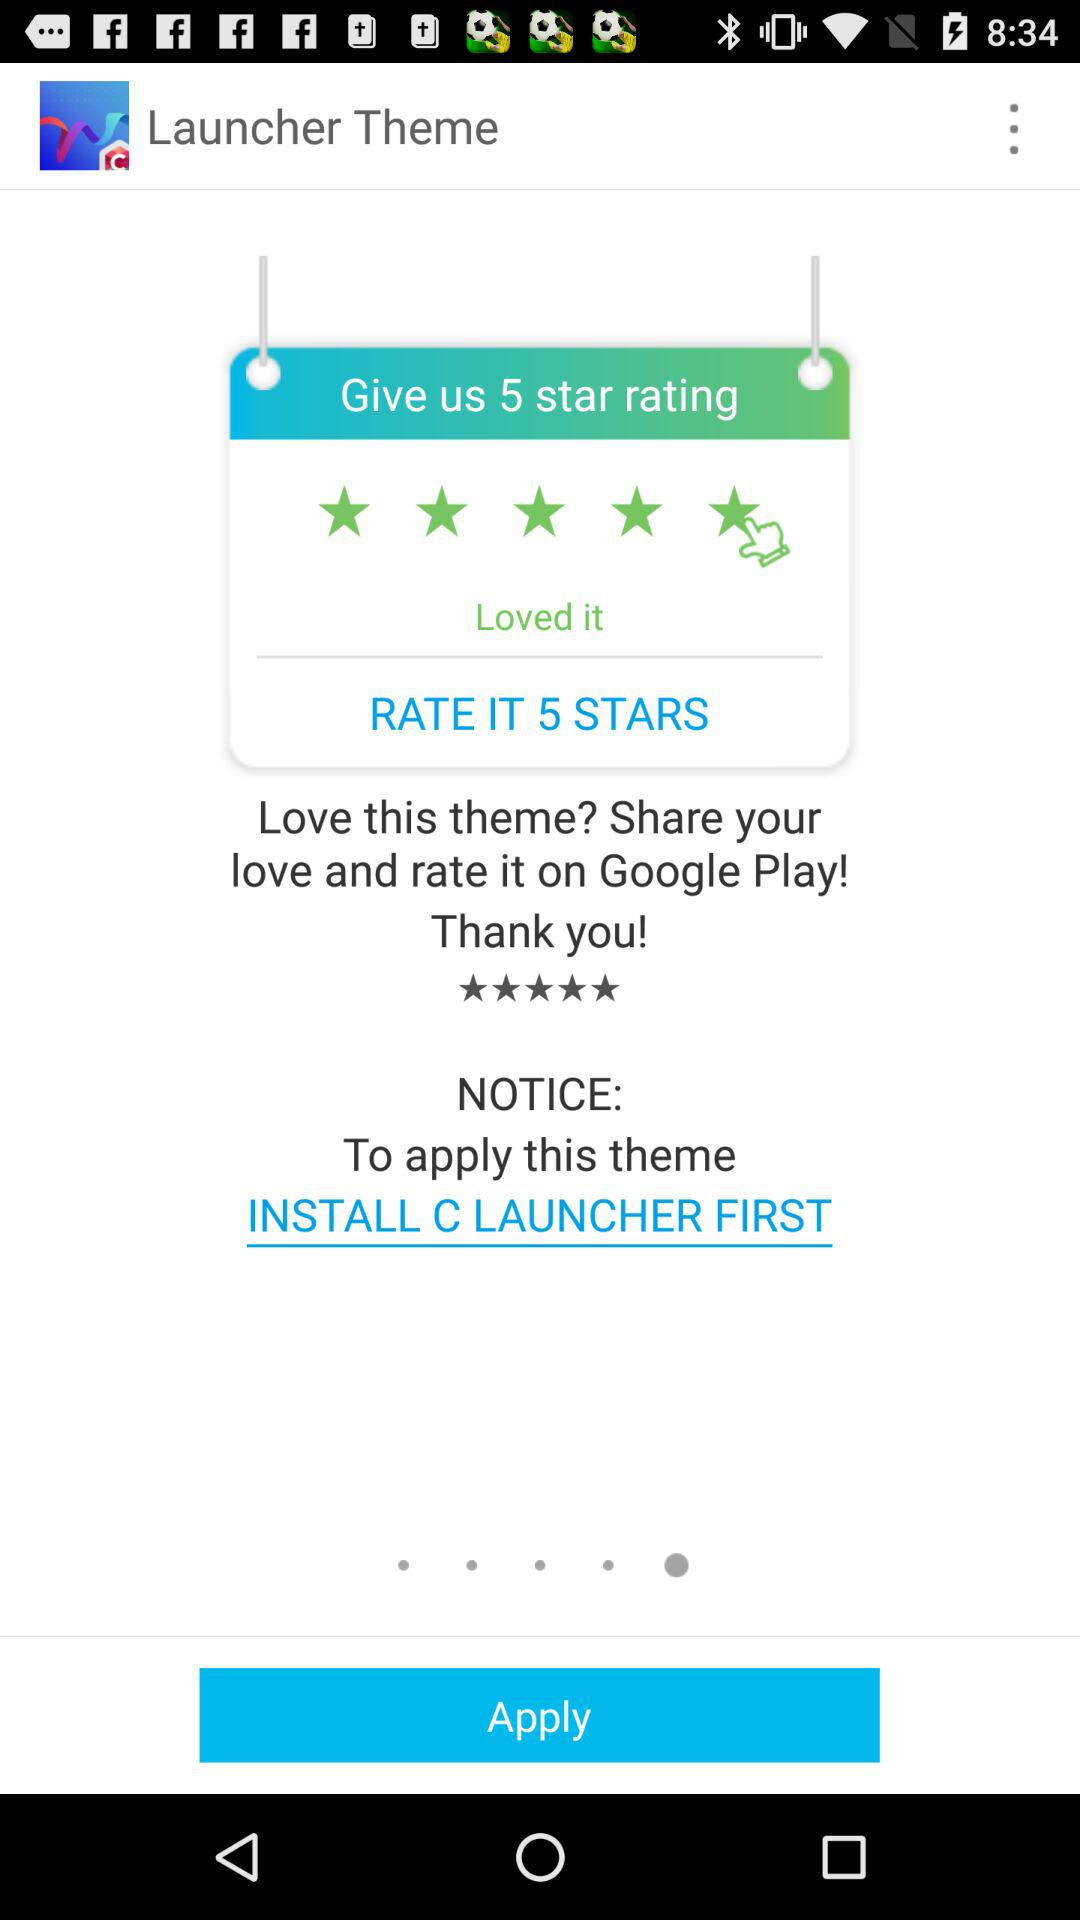What is the rating?
When the provided information is insufficient, respond with <no answer>. <no answer> 